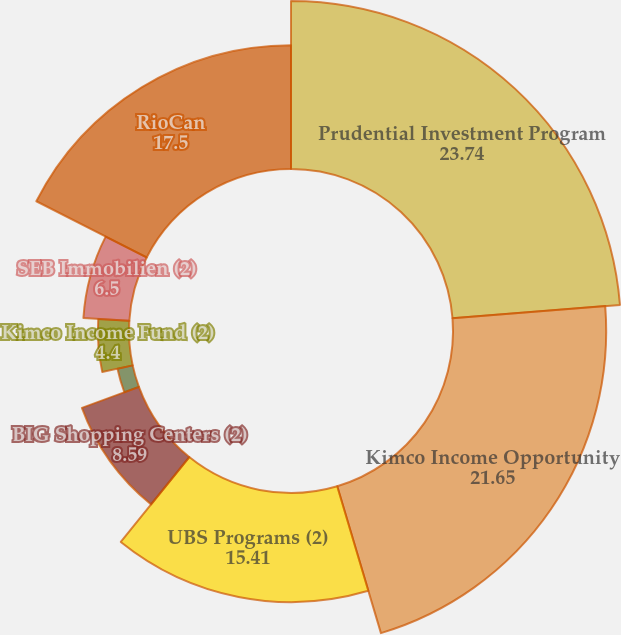Convert chart. <chart><loc_0><loc_0><loc_500><loc_500><pie_chart><fcel>Prudential Investment Program<fcel>Kimco Income Opportunity<fcel>UBS Programs (2)<fcel>BIG Shopping Centers (2)<fcel>The Canada Pension Plan<fcel>Kimco Income Fund (2)<fcel>SEB Immobilien (2)<fcel>RioCan<nl><fcel>23.74%<fcel>21.65%<fcel>15.41%<fcel>8.59%<fcel>2.2%<fcel>4.4%<fcel>6.5%<fcel>17.5%<nl></chart> 